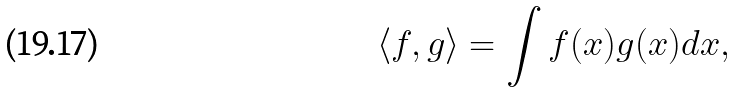Convert formula to latex. <formula><loc_0><loc_0><loc_500><loc_500>\left \langle f , g \right \rangle = \int f ( x ) g ( x ) d x ,</formula> 